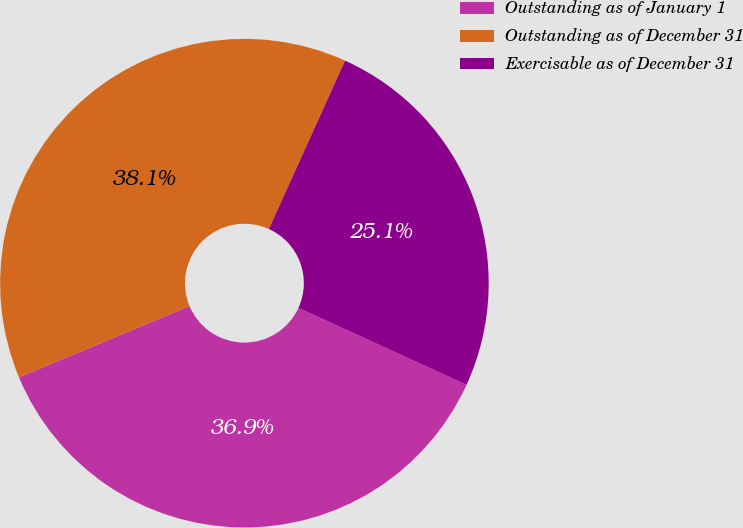Convert chart. <chart><loc_0><loc_0><loc_500><loc_500><pie_chart><fcel>Outstanding as of January 1<fcel>Outstanding as of December 31<fcel>Exercisable as of December 31<nl><fcel>36.87%<fcel>38.05%<fcel>25.07%<nl></chart> 